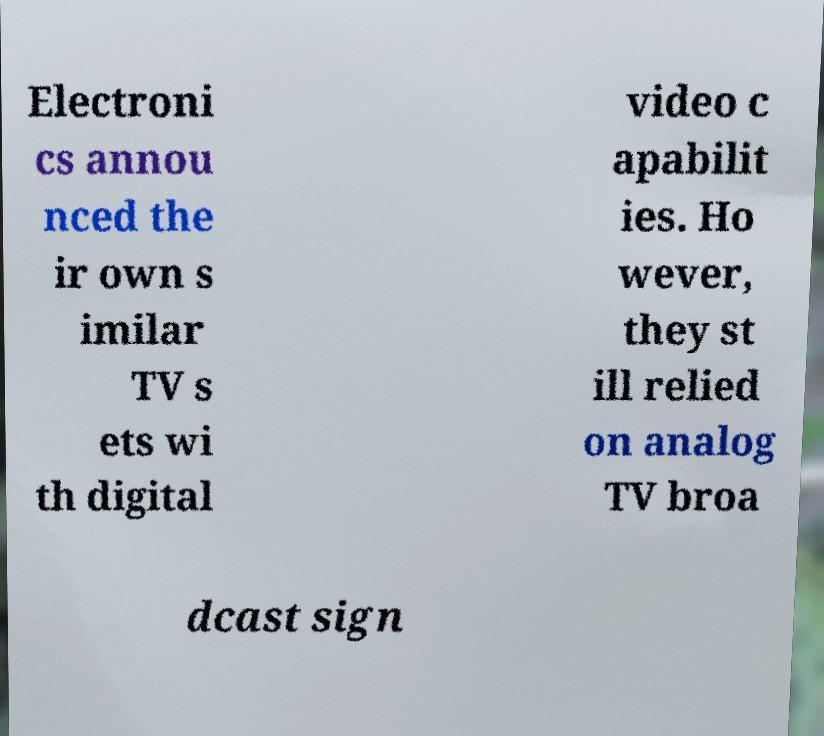Please identify and transcribe the text found in this image. Electroni cs annou nced the ir own s imilar TV s ets wi th digital video c apabilit ies. Ho wever, they st ill relied on analog TV broa dcast sign 